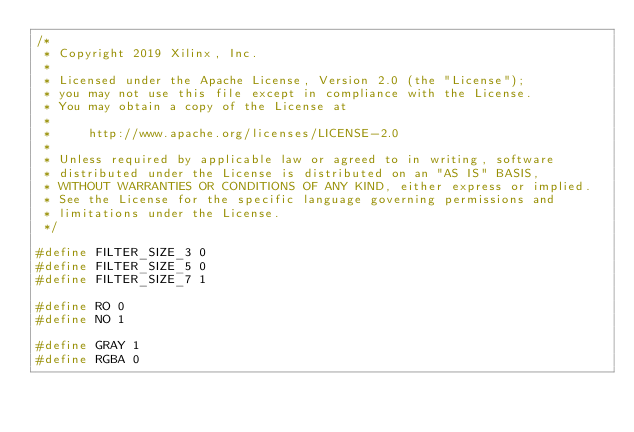<code> <loc_0><loc_0><loc_500><loc_500><_C_>/*
 * Copyright 2019 Xilinx, Inc.
 *
 * Licensed under the Apache License, Version 2.0 (the "License");
 * you may not use this file except in compliance with the License.
 * You may obtain a copy of the License at
 *
 *     http://www.apache.org/licenses/LICENSE-2.0
 *
 * Unless required by applicable law or agreed to in writing, software
 * distributed under the License is distributed on an "AS IS" BASIS,
 * WITHOUT WARRANTIES OR CONDITIONS OF ANY KIND, either express or implied.
 * See the License for the specific language governing permissions and
 * limitations under the License.
 */

#define FILTER_SIZE_3 0
#define FILTER_SIZE_5 0
#define FILTER_SIZE_7 1

#define RO 0
#define NO 1

#define GRAY 1
#define RGBA 0
</code> 